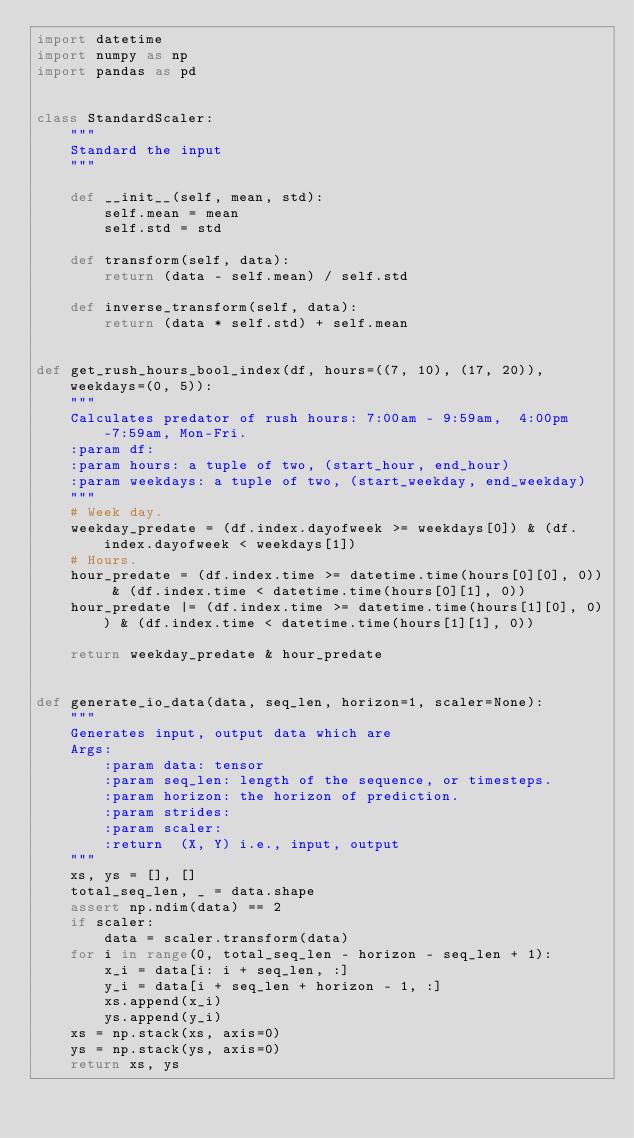Convert code to text. <code><loc_0><loc_0><loc_500><loc_500><_Python_>import datetime
import numpy as np
import pandas as pd


class StandardScaler:
    """
    Standard the input
    """

    def __init__(self, mean, std):
        self.mean = mean
        self.std = std

    def transform(self, data):
        return (data - self.mean) / self.std

    def inverse_transform(self, data):
        return (data * self.std) + self.mean


def get_rush_hours_bool_index(df, hours=((7, 10), (17, 20)), weekdays=(0, 5)):
    """
    Calculates predator of rush hours: 7:00am - 9:59am,  4:00pm-7:59am, Mon-Fri.
    :param df:
    :param hours: a tuple of two, (start_hour, end_hour)
    :param weekdays: a tuple of two, (start_weekday, end_weekday)
    """
    # Week day.
    weekday_predate = (df.index.dayofweek >= weekdays[0]) & (df.index.dayofweek < weekdays[1])
    # Hours.
    hour_predate = (df.index.time >= datetime.time(hours[0][0], 0)) & (df.index.time < datetime.time(hours[0][1], 0))
    hour_predate |= (df.index.time >= datetime.time(hours[1][0], 0)) & (df.index.time < datetime.time(hours[1][1], 0))

    return weekday_predate & hour_predate


def generate_io_data(data, seq_len, horizon=1, scaler=None):
    """
    Generates input, output data which are
    Args:
        :param data: tensor
        :param seq_len: length of the sequence, or timesteps.
        :param horizon: the horizon of prediction.
        :param strides:
        :param scaler:
        :return  (X, Y) i.e., input, output
    """
    xs, ys = [], []
    total_seq_len, _ = data.shape
    assert np.ndim(data) == 2
    if scaler:
        data = scaler.transform(data)
    for i in range(0, total_seq_len - horizon - seq_len + 1):
        x_i = data[i: i + seq_len, :]
        y_i = data[i + seq_len + horizon - 1, :]
        xs.append(x_i)
        ys.append(y_i)
    xs = np.stack(xs, axis=0)
    ys = np.stack(ys, axis=0)
    return xs, ys

</code> 